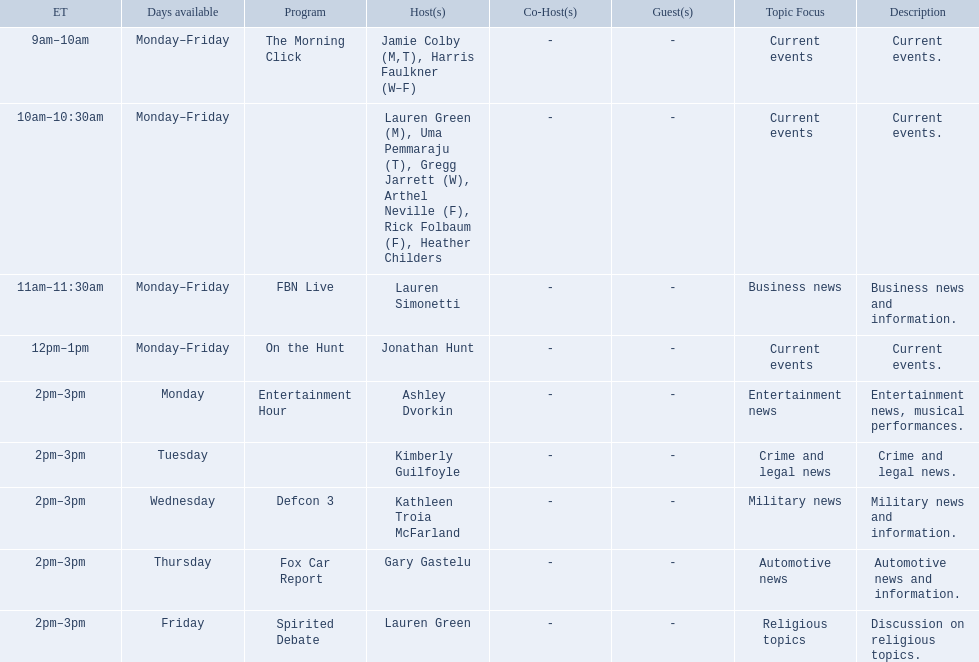Which programs broadcast by fox news channel hosts are listed? Jamie Colby (M,T), Harris Faulkner (W–F), Lauren Green (M), Uma Pemmaraju (T), Gregg Jarrett (W), Arthel Neville (F), Rick Folbaum (F), Heather Childers, Lauren Simonetti, Jonathan Hunt, Ashley Dvorkin, Kimberly Guilfoyle, Kathleen Troia McFarland, Gary Gastelu, Lauren Green. Of those, who have shows on friday? Jamie Colby (M,T), Harris Faulkner (W–F), Lauren Green (M), Uma Pemmaraju (T), Gregg Jarrett (W), Arthel Neville (F), Rick Folbaum (F), Heather Childers, Lauren Simonetti, Jonathan Hunt, Lauren Green. Of those, whose is at 2 pm? Lauren Green. 